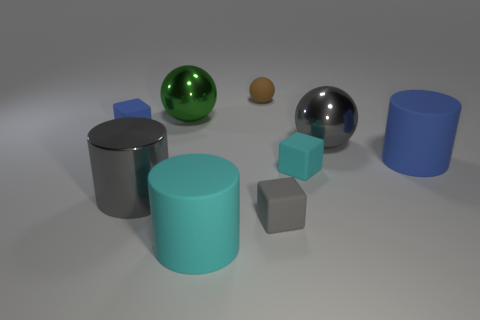Subtract all big spheres. How many spheres are left? 1 Subtract 1 balls. How many balls are left? 2 Subtract all cyan blocks. How many blocks are left? 2 Subtract all cylinders. How many objects are left? 6 Add 5 large gray cylinders. How many large gray cylinders are left? 6 Add 6 gray rubber blocks. How many gray rubber blocks exist? 7 Subtract 0 purple balls. How many objects are left? 9 Subtract all cyan cubes. Subtract all blue balls. How many cubes are left? 2 Subtract all cyan blocks. How many brown spheres are left? 1 Subtract all big shiny cylinders. Subtract all cyan objects. How many objects are left? 6 